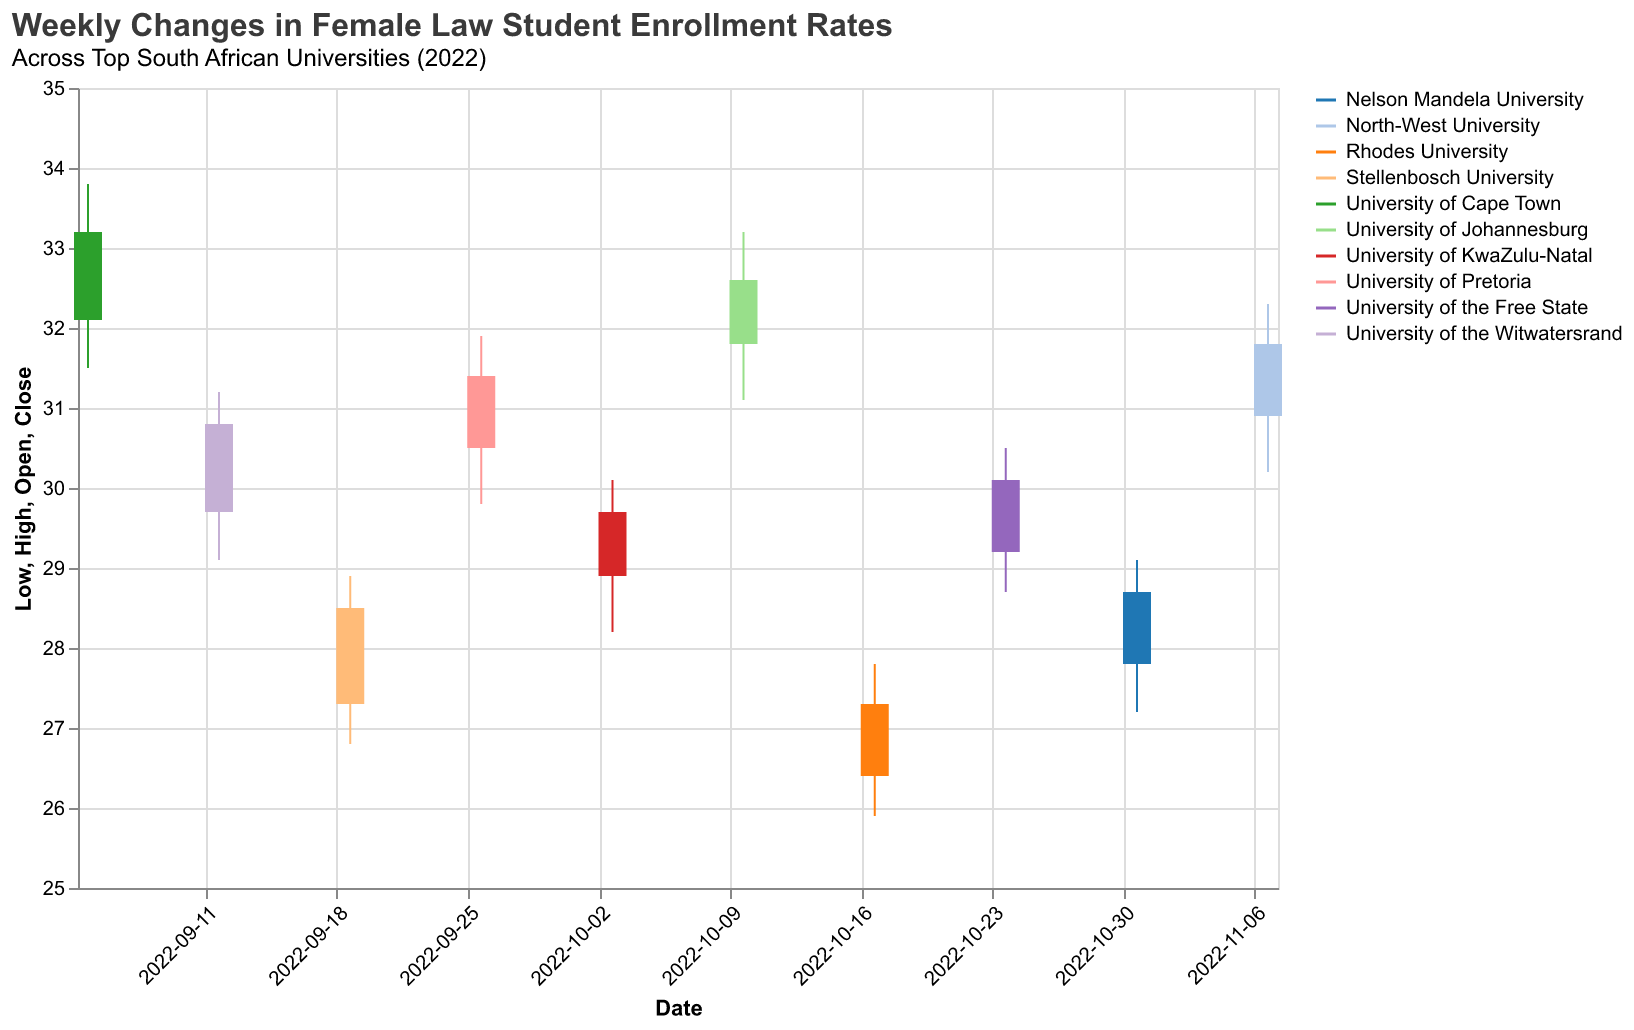What is the title of the figure? The title can be identified at the top of the figure.
Answer: "Weekly Changes in Female Law Student Enrollment Rates" Which university had the highest closing enrollment rate during the week of October 10, 2022? Look for October 10, 2022, and identify which university had the highest 'Close' value.
Answer: University of Johannesburg What was the opening enrollment rate for the University of Pretoria on September 26, 2022? Find the data point for September 26, 2022, and note the 'Open' value.
Answer: 30.5 Which university had the smallest range (difference between High and Low) in enrollment rates during the observed period? Calculate the range (High - Low) for each university, and find the smallest value.
Answer: Rhodes University What is the average closing enrollment rate for all universities over the observed period? Sum up all the 'Close' values and divide by the number of weeks.
Answer: 30.61 Compare the closing enrollment rates between Nelson Mandela University and North-West University on their respective weeks. Which had a higher closing rate? Look at the 'Close' values for both universities on their given dates and compare.
Answer: North-West University How did the enrollment rate for Stellenbosch University change from its opening to its closing rate on September 19, 2022? Note the 'Open' and 'Close' values for September 19, 2022, and calculate the difference (Close - Open).
Answer: Increased by 1.2 Which university experienced the largest single-week increase in enrollment, and what was the amount of increase? Identify the week where the difference (Close - Open) is the largest and note the university and amount.
Answer: University of Cape Town, 1.1 How many universities had a closing enrollment rate above 30.0 during the week of October 3, 2022? Look at October 3, 2022, and count the universities with a 'Close' value greater than 30.0.
Answer: None Between the University of Cape Town and the University of Johannesburg, which had a higher average enrollment rate over the weeks provided in the data? Calculate the average of 'Close' values for both universities and compare the results.
Answer: University of Cape Town 